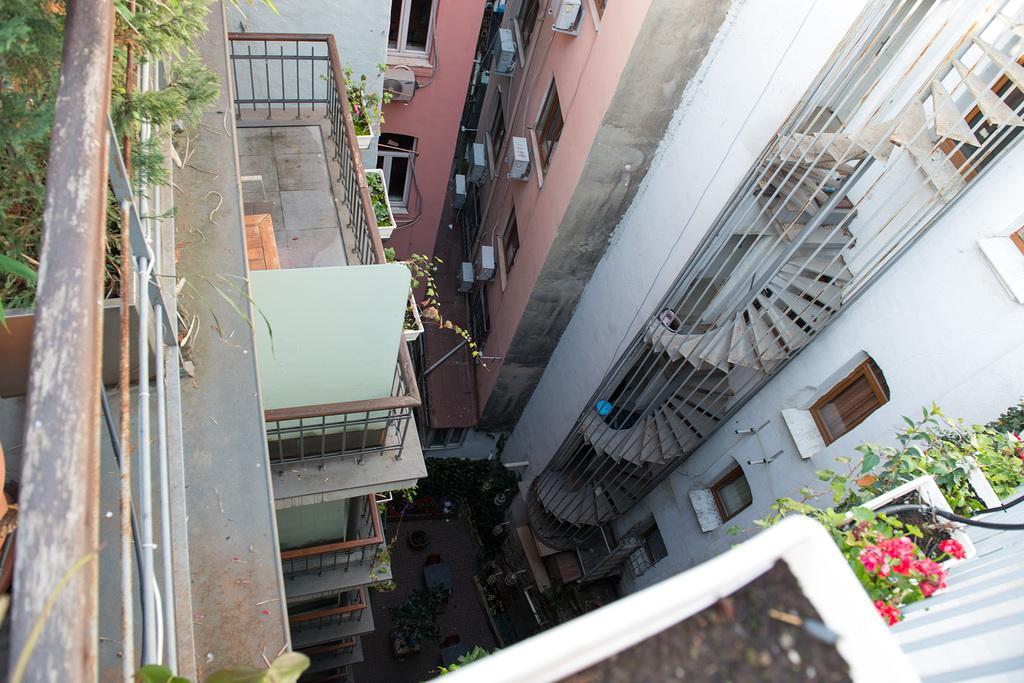In one or two sentences, can you explain what this image depicts? On the left side of the picture, we see an iron railing and the plants. In the right bottom of the picture, we see flower pots and plants. In this picture, we see buildings, iron railings and the plants. 